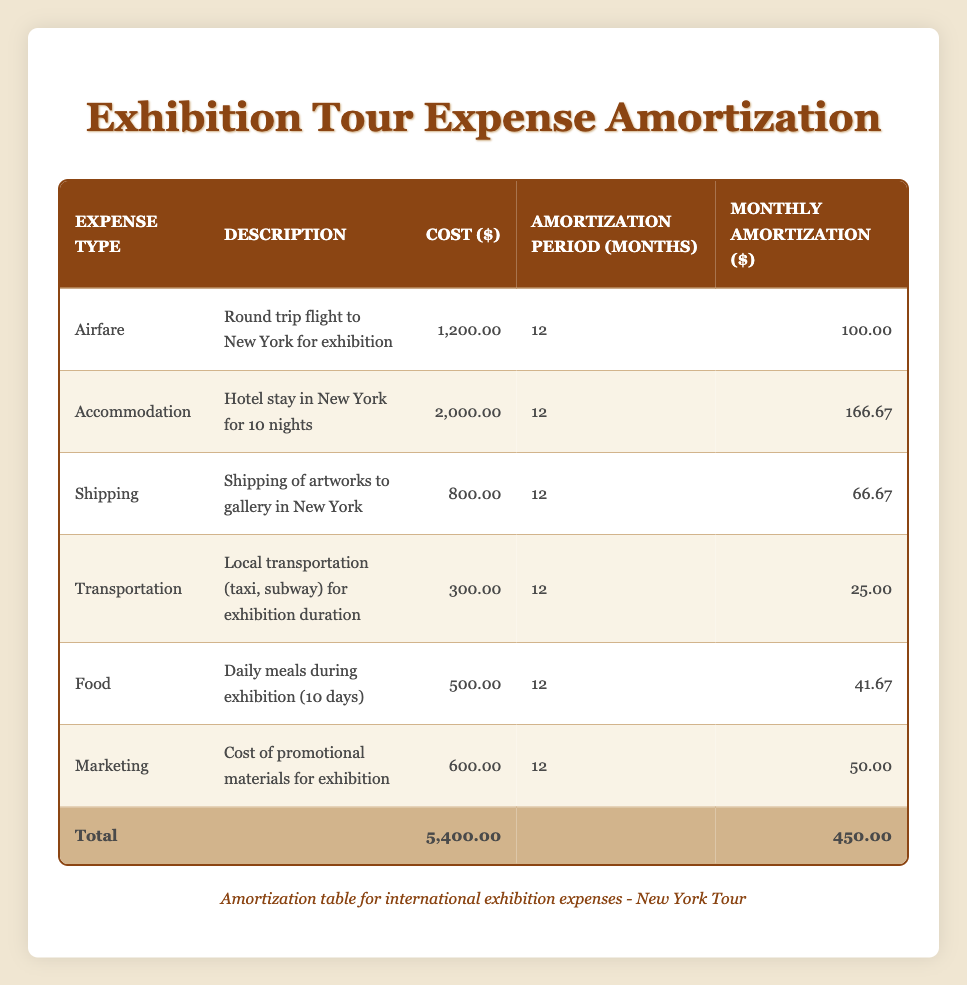What is the total cost of all travel expenses? To find the total cost, we sum up all the costs listed in the table: 1200 (Airfare) + 2000 (Accommodation) + 800 (Shipping) + 300 (Transportation) + 500 (Food) + 600 (Marketing) = 5400.
Answer: 5400 How much is the monthly amortization for the Accommodation expense? The table shows that the cost for Accommodation is 2000, and the amortization period is 12 months. So, the monthly amortization is calculated as 2000/12 = 166.67.
Answer: 166.67 Is the Shipping expense greater than the Transportation expense? The cost of Shipping is 800, while the cost of Transportation is 300. Since 800 is greater than 300, the statement is true.
Answer: Yes What is the total monthly amortization for all expenses combined? To calculate the total monthly amortization, we take the monthly amortization for each expense: 100 (Airfare) + 166.67 (Accommodation) + 66.67 (Shipping) + 25 (Transportation) + 41.67 (Food) + 50 (Marketing) = 450.
Answer: 450 Which expense has the highest monthly amortization? Comparing the monthly amortization for each expense: 100 (Airfare), 166.67 (Accommodation), 66.67 (Shipping), 25 (Transportation), 41.67 (Food), and 50 (Marketing). The highest is 166.67 for Accommodation.
Answer: Accommodation If I only had a budget of 500 for monthly expenses, what expenses would I have to omit to stay within budget? The total monthly amortization is 450. To stay within a budget of 500, we cannot omit any expenses since the total is lower than the budget. Therefore, all expenses can be included.
Answer: None What is the average cost of all travel expenses? There are 6 expenses, so we calculate the average by dividing the total cost by the number of expenses: 5400 (total cost) / 6 (expenses) = 900.
Answer: 900 How much less is the cost of Food compared to Marketing? The cost of Food is 500, and the cost of Marketing is 600. The difference is calculated as 600 - 500 = 100.
Answer: 100 Is the total cost of Airfare and Food greater than that of Marketing and Transportation combined? The total cost of Airfare and Food is 1200 (Airfare) + 500 (Food) = 1700. The total for Marketing and Transportation is 600 + 300 = 900. Since 1700 is greater than 900, the statement is true.
Answer: Yes 